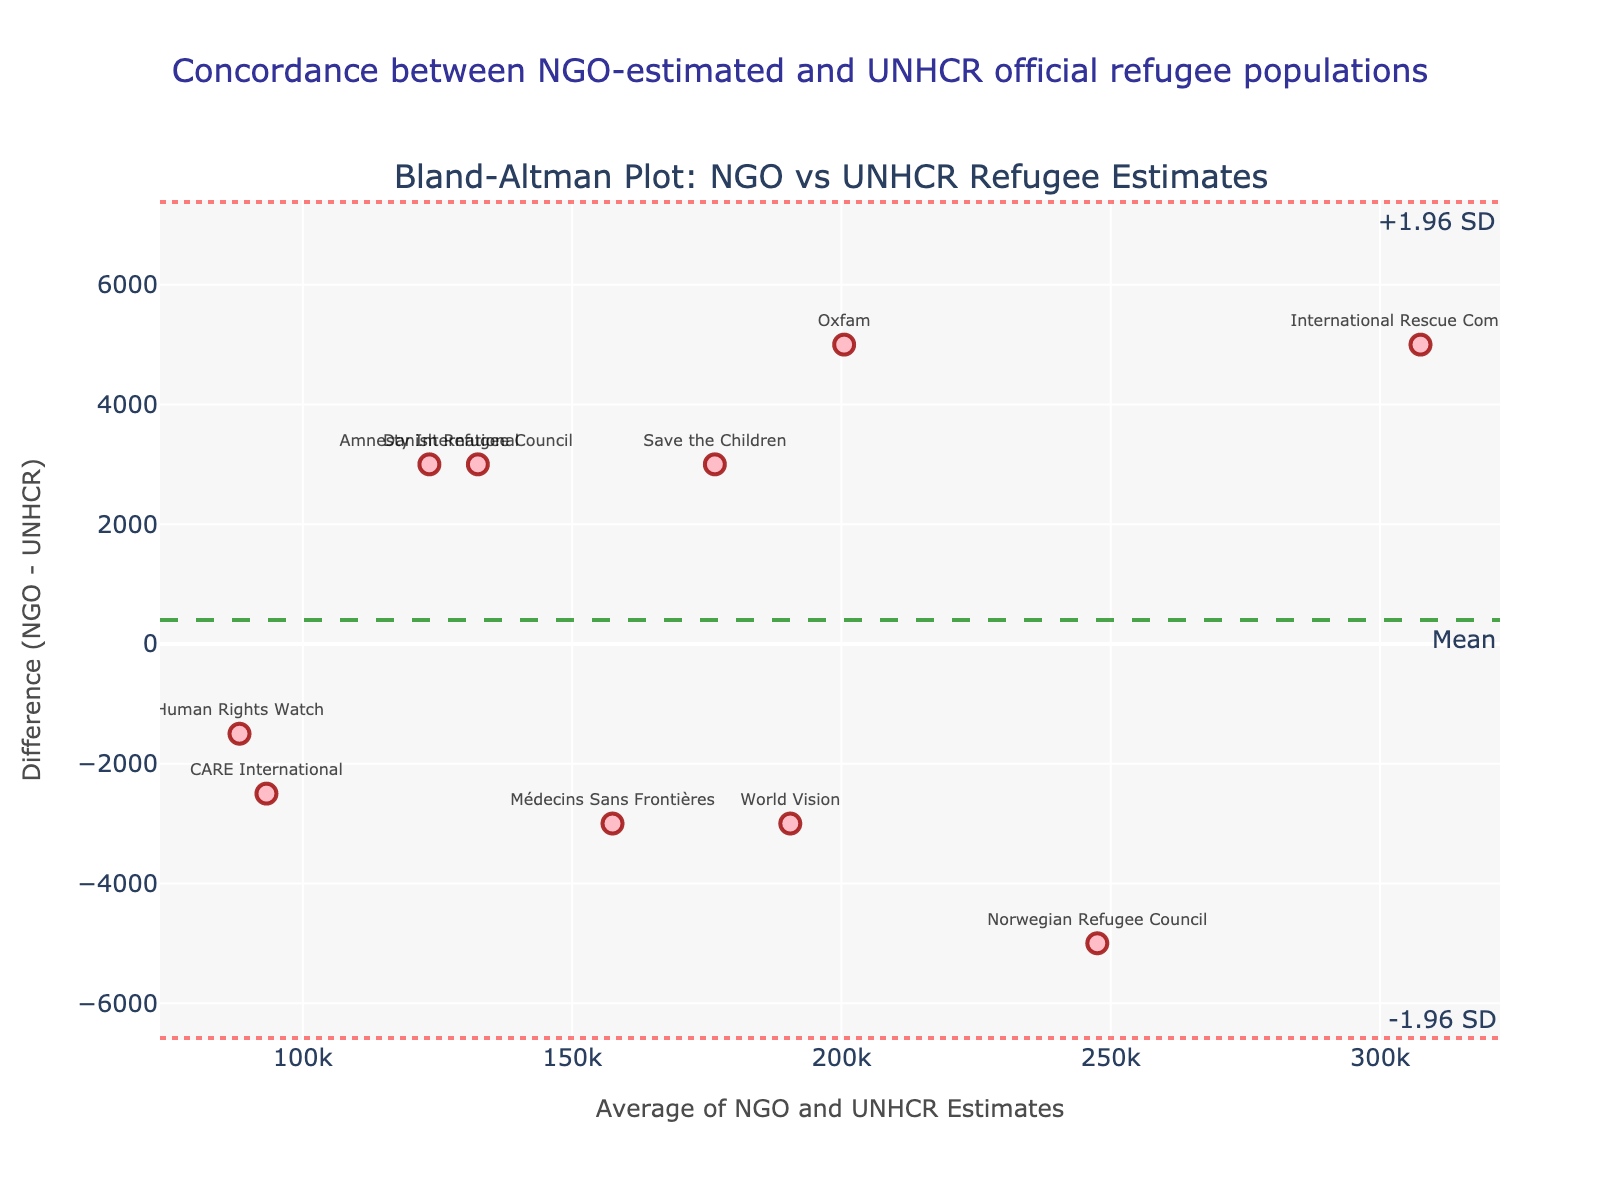What is the title of the figure? The title is easily observable at the top of the figure. It provides a brief description of what the plot represents.
Answer: Concordance between NGO-estimated and UNHCR official refugee populations What are the x-axis and y-axis labels in this plot? The x-axis and y-axis labels are part of the figure and describe what is being measured on each axis. The x-axis label pertains to the average number of refugee estimates from NGOs and UNHCR, and the y-axis label refers to the difference between these estimates.
Answer: Average of NGO and UNHCR Estimates; Difference (NGO - UNHCR) How many data points are plotted in this figure? The number of data points can be counted by looking at each marker representing an NGO in the plot. Each marker corresponds to one data point.
Answer: 10 Which NGO shows the largest positive difference between its estimate and the UNHCR official figure? By comparing the difference values on the y-axis, we identify the marker that is farthest above the zero line. The NGO label on this marker provides the answer.
Answer: International Rescue Committee What are the values of the upper and lower limits of agreement in this plot? These limits are represented by the dotted lines in the plot and are annotated with their respective positions on the y-axis.
Answer: +1.96 SD: 6295; -1.96 SD: -9495 What is the mean difference between NGO estimates and UNHCR official figures? The mean difference is indicated by a dashed line in the plot and annotated with its position on the y-axis.
Answer: 1400 Which NGO's estimate is closest to the UNHCR official figure? The NGO whose difference value is closest to zero represents the smallest deviation between estimates. Identify the marker closest to the zero line and check its label.
Answer: Amnesty International Which two NGOs have the largest differences in their refugee estimates from the UNHCR figures? By checking the markers at the extreme positive and negative values on the y-axis, we find the NGOs with the largest discrepancies.
Answer: International Rescue Committee (largest positive difference) and Danish Refugee Council (largest negative difference) Do any NGOs show a negative difference between their estimates and the UNHCR official figures? Negative differences are indicated by markers below the zero line on the y-axis.
Answer: Yes What does the Bland-Altman plot suggest about the concordance of refugee estimates between NGOs and UNHCR? This type of plot is used to assess the agreement between two measurement methods. By examining the spread and central tendency of the differences, as well as comparing the mean difference to the limits of agreement, one can infer the level of concordance.
Answer: There is generally good concordance, but some NGOs show significant differences 